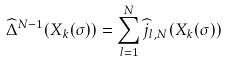Convert formula to latex. <formula><loc_0><loc_0><loc_500><loc_500>\widehat { \Delta } ^ { N - 1 } ( X _ { k } ( \sigma ) ) = \sum _ { l = 1 } ^ { N } \widehat { j } _ { l , N } ( X _ { k } ( \sigma ) )</formula> 